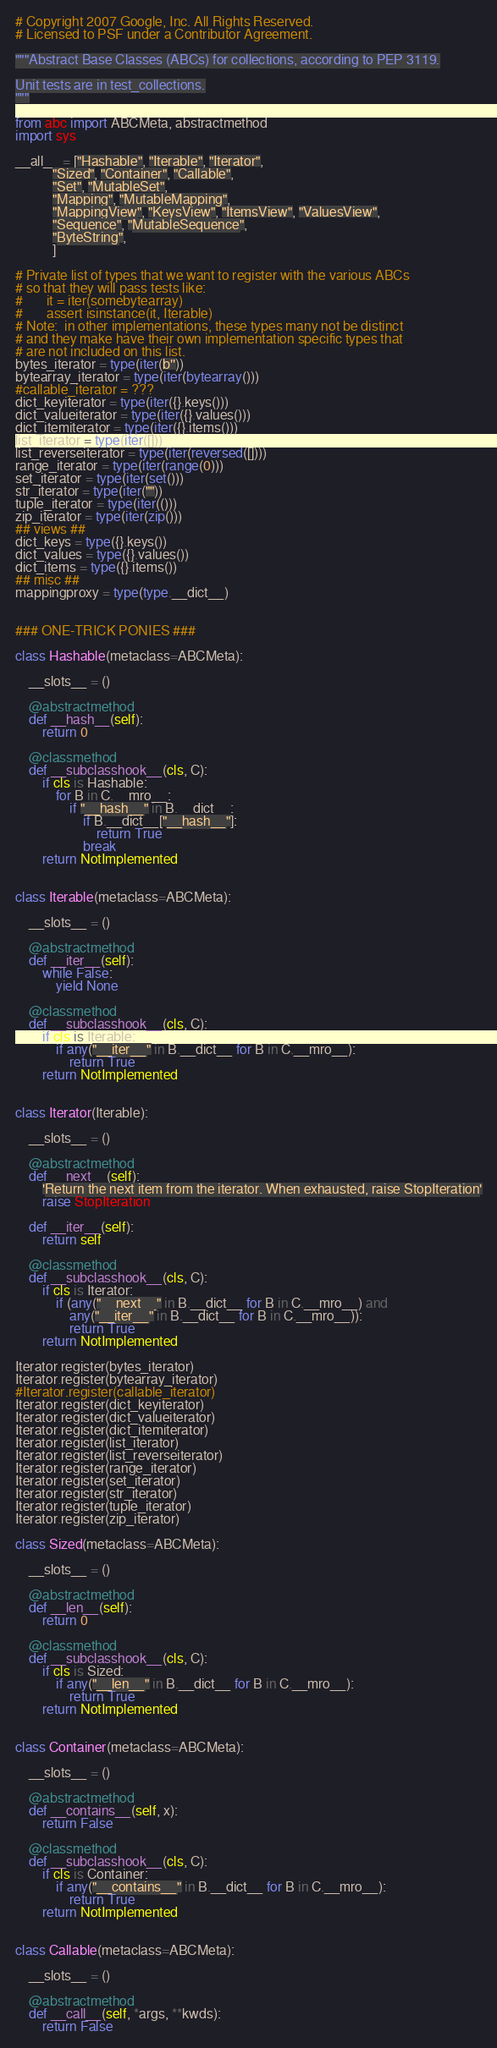Convert code to text. <code><loc_0><loc_0><loc_500><loc_500><_Python_># Copyright 2007 Google, Inc. All Rights Reserved.
# Licensed to PSF under a Contributor Agreement.

"""Abstract Base Classes (ABCs) for collections, according to PEP 3119.

Unit tests are in test_collections.
"""

from abc import ABCMeta, abstractmethod
import sys

__all__ = ["Hashable", "Iterable", "Iterator",
           "Sized", "Container", "Callable",
           "Set", "MutableSet",
           "Mapping", "MutableMapping",
           "MappingView", "KeysView", "ItemsView", "ValuesView",
           "Sequence", "MutableSequence",
           "ByteString",
           ]

# Private list of types that we want to register with the various ABCs
# so that they will pass tests like:
#       it = iter(somebytearray)
#       assert isinstance(it, Iterable)
# Note:  in other implementations, these types many not be distinct
# and they make have their own implementation specific types that
# are not included on this list.
bytes_iterator = type(iter(b''))
bytearray_iterator = type(iter(bytearray()))
#callable_iterator = ???
dict_keyiterator = type(iter({}.keys()))
dict_valueiterator = type(iter({}.values()))
dict_itemiterator = type(iter({}.items()))
list_iterator = type(iter([]))
list_reverseiterator = type(iter(reversed([])))
range_iterator = type(iter(range(0)))
set_iterator = type(iter(set()))
str_iterator = type(iter(""))
tuple_iterator = type(iter(()))
zip_iterator = type(iter(zip()))
## views ##
dict_keys = type({}.keys())
dict_values = type({}.values())
dict_items = type({}.items())
## misc ##
mappingproxy = type(type.__dict__)


### ONE-TRICK PONIES ###

class Hashable(metaclass=ABCMeta):

    __slots__ = ()

    @abstractmethod
    def __hash__(self):
        return 0

    @classmethod
    def __subclasshook__(cls, C):
        if cls is Hashable:
            for B in C.__mro__:
                if "__hash__" in B.__dict__:
                    if B.__dict__["__hash__"]:
                        return True
                    break
        return NotImplemented


class Iterable(metaclass=ABCMeta):

    __slots__ = ()

    @abstractmethod
    def __iter__(self):
        while False:
            yield None

    @classmethod
    def __subclasshook__(cls, C):
        if cls is Iterable:
            if any("__iter__" in B.__dict__ for B in C.__mro__):
                return True
        return NotImplemented


class Iterator(Iterable):

    __slots__ = ()

    @abstractmethod
    def __next__(self):
        'Return the next item from the iterator. When exhausted, raise StopIteration'
        raise StopIteration

    def __iter__(self):
        return self

    @classmethod
    def __subclasshook__(cls, C):
        if cls is Iterator:
            if (any("__next__" in B.__dict__ for B in C.__mro__) and
                any("__iter__" in B.__dict__ for B in C.__mro__)):
                return True
        return NotImplemented

Iterator.register(bytes_iterator)
Iterator.register(bytearray_iterator)
#Iterator.register(callable_iterator)
Iterator.register(dict_keyiterator)
Iterator.register(dict_valueiterator)
Iterator.register(dict_itemiterator)
Iterator.register(list_iterator)
Iterator.register(list_reverseiterator)
Iterator.register(range_iterator)
Iterator.register(set_iterator)
Iterator.register(str_iterator)
Iterator.register(tuple_iterator)
Iterator.register(zip_iterator)

class Sized(metaclass=ABCMeta):

    __slots__ = ()

    @abstractmethod
    def __len__(self):
        return 0

    @classmethod
    def __subclasshook__(cls, C):
        if cls is Sized:
            if any("__len__" in B.__dict__ for B in C.__mro__):
                return True
        return NotImplemented


class Container(metaclass=ABCMeta):

    __slots__ = ()

    @abstractmethod
    def __contains__(self, x):
        return False

    @classmethod
    def __subclasshook__(cls, C):
        if cls is Container:
            if any("__contains__" in B.__dict__ for B in C.__mro__):
                return True
        return NotImplemented


class Callable(metaclass=ABCMeta):

    __slots__ = ()

    @abstractmethod
    def __call__(self, *args, **kwds):
        return False
</code> 